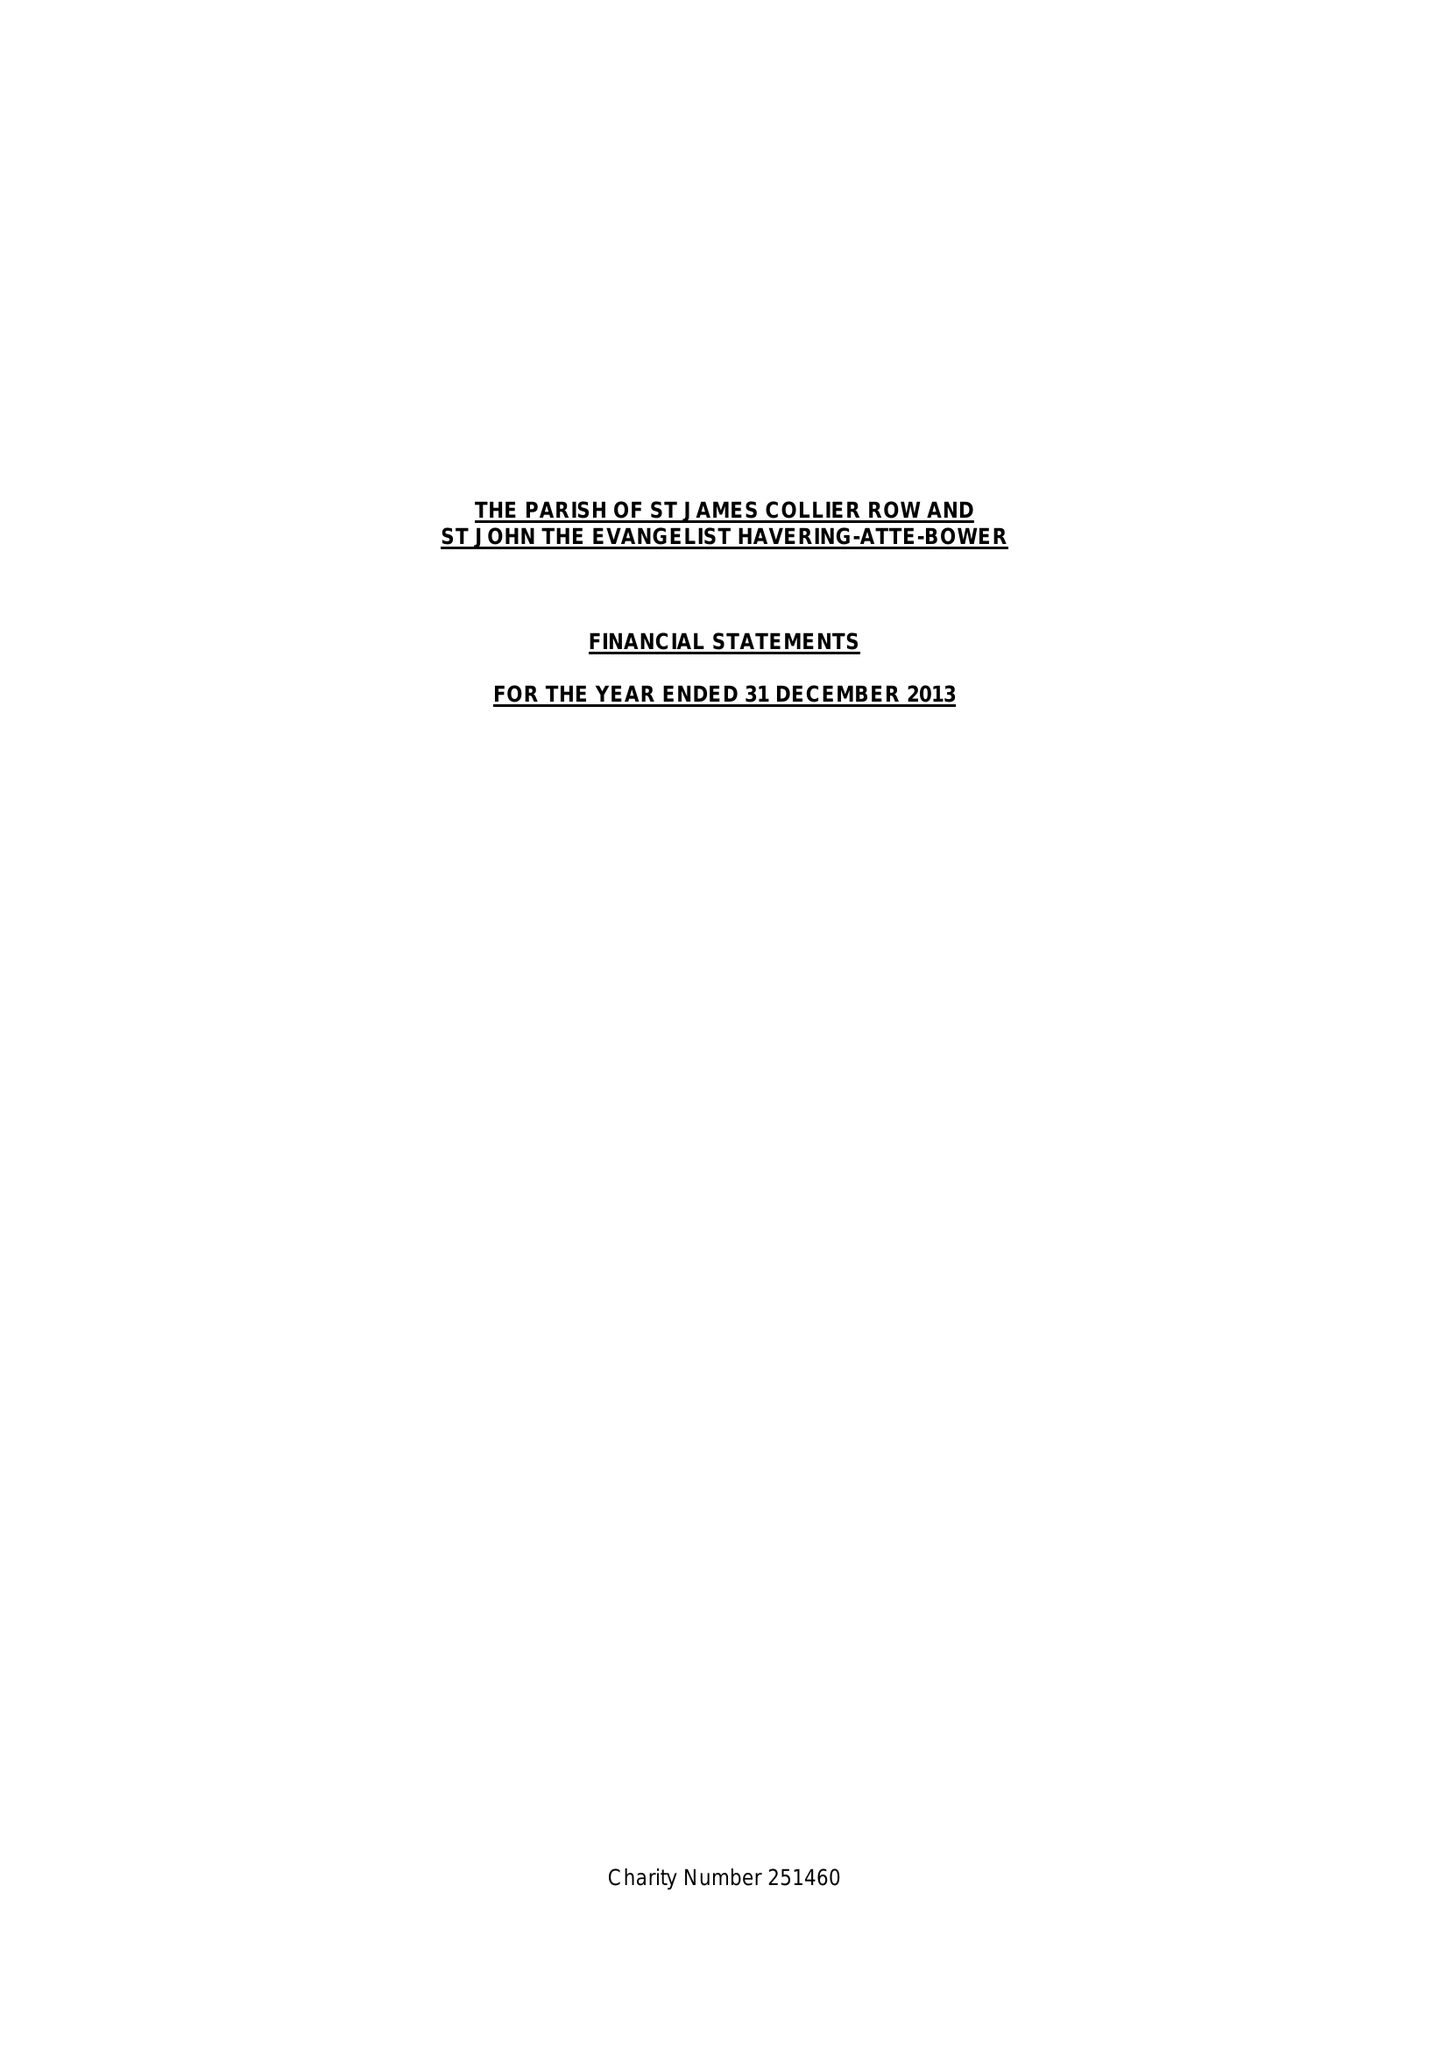What is the value for the address__street_line?
Answer the question using a single word or phrase. 21 LINKS AVENUE 